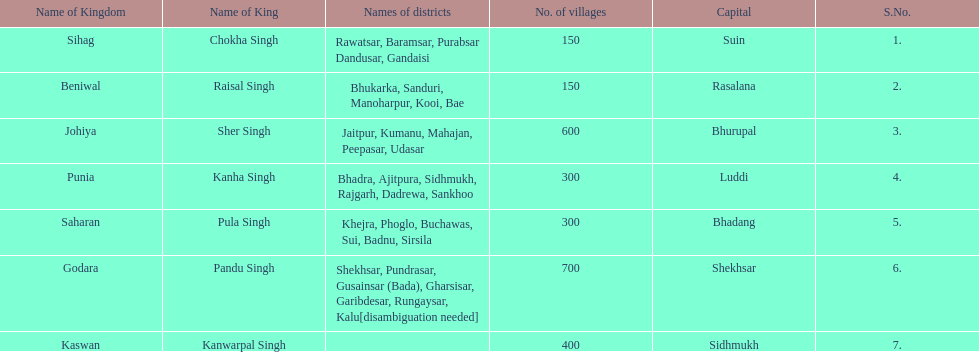How many districts does punia have? 6. 